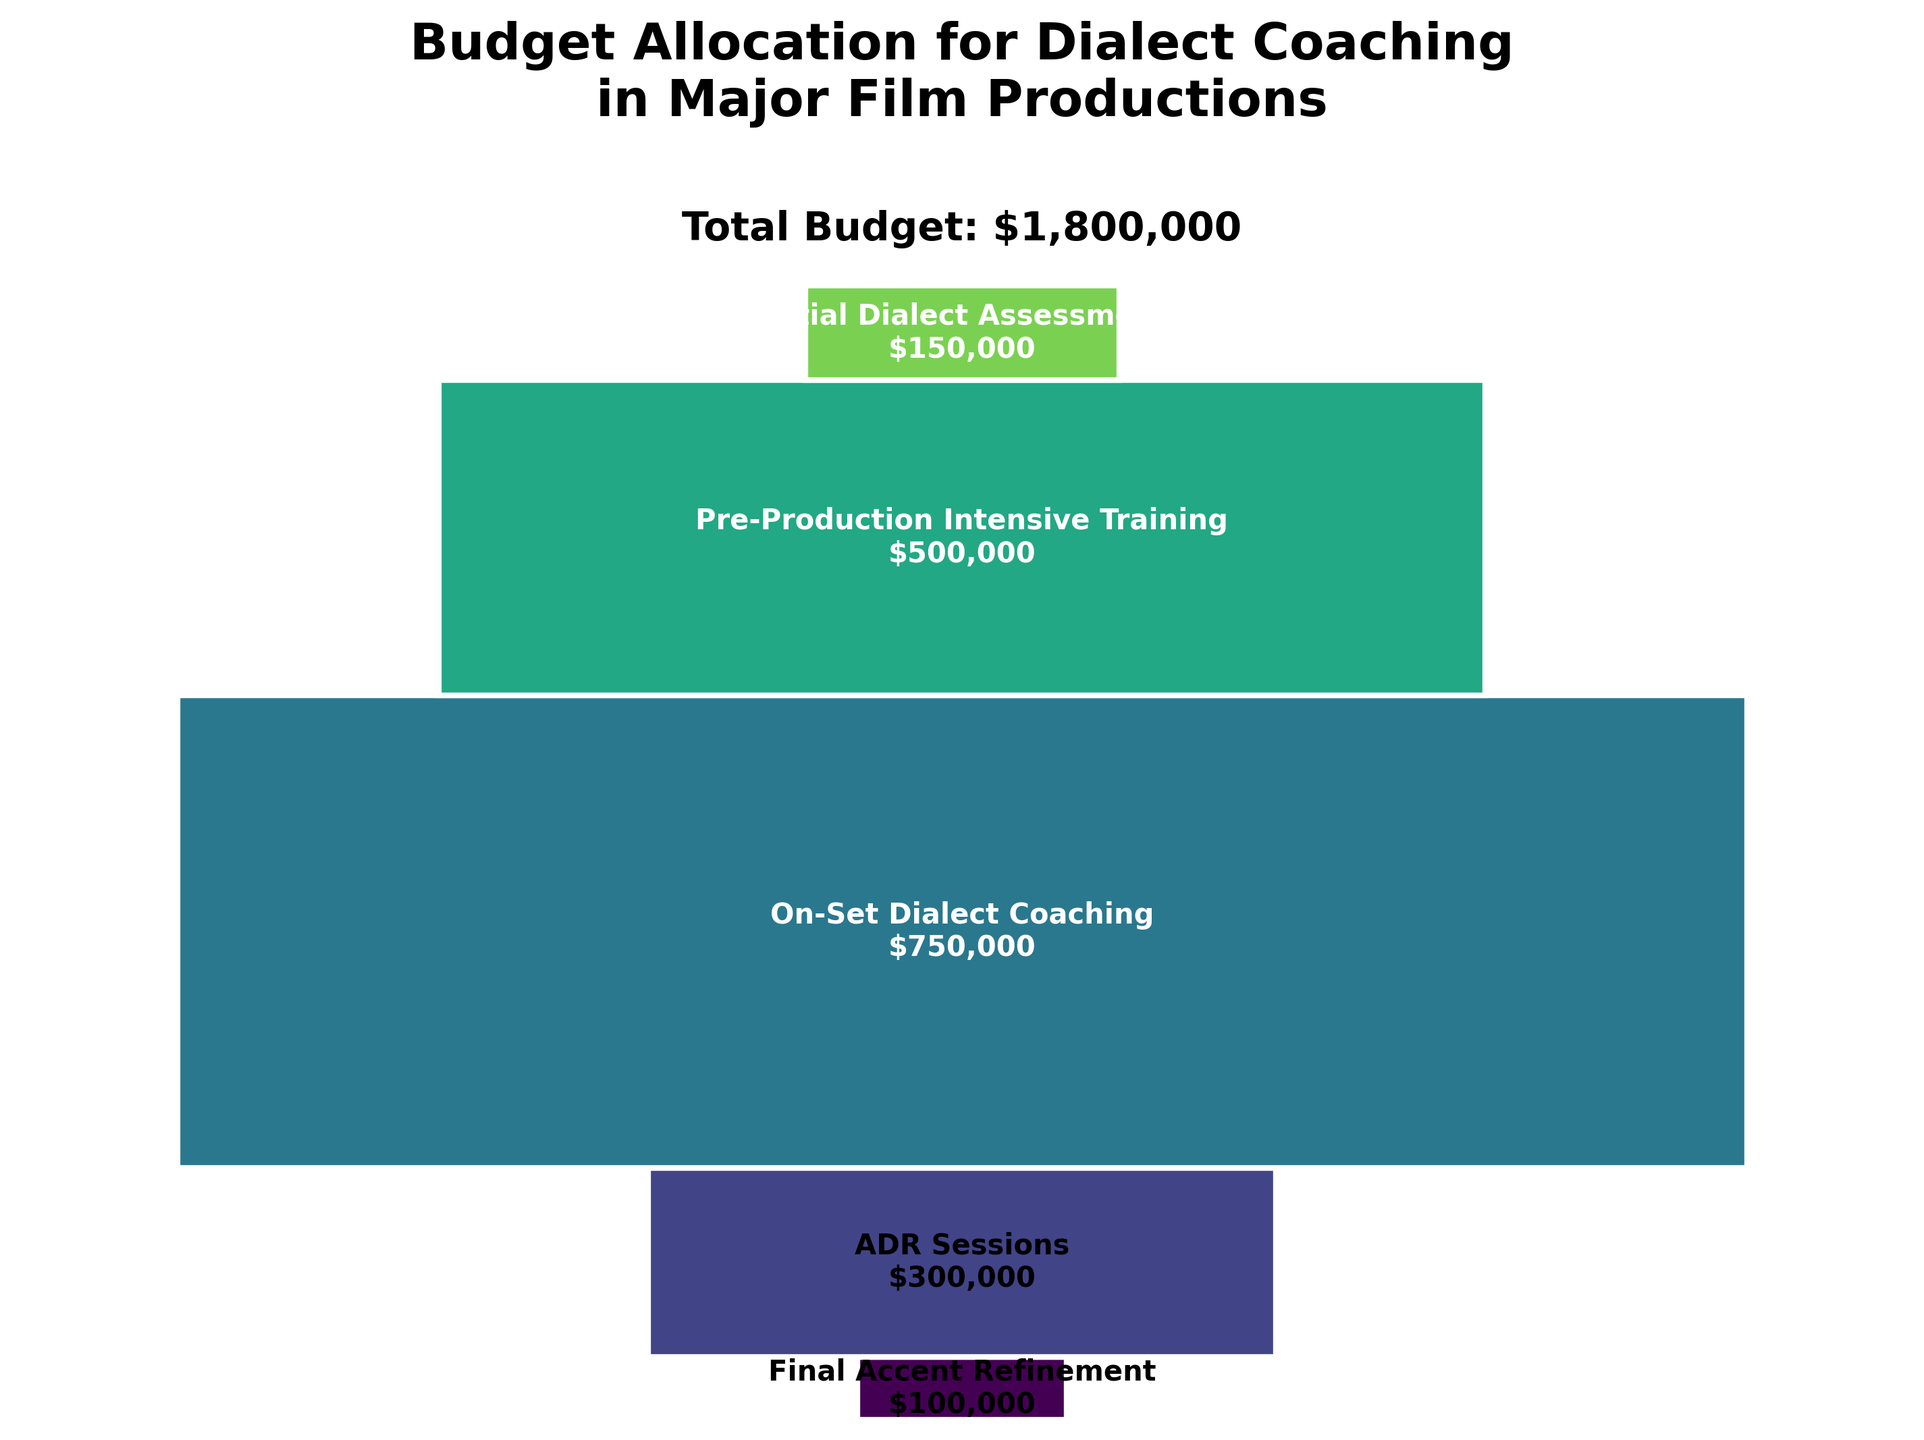What is the title of the plot? The title of the plot is prominently displayed at the top of the figure. It reads "Budget Allocation for Dialect Coaching in Major Film Productions".
Answer: Budget Allocation for Dialect Coaching in Major Film Productions How much budget is allocated for ADR Sessions? The data in the chart shows the budget allocations for different stages. For ADR Sessions, the text displayed within the corresponding bar indicates $300,000.
Answer: $300,000 What stage has the highest budget allocation? By looking at the size of the bars in the funnel chart, the stage with the largest bar represents the highest budget allocation, which is "On-Set Dialect Coaching" with $750,000.
Answer: On-Set Dialect Coaching What is the total budget allocated across all stages? The total budget is shown at the top of the plot, calculated by summing the individual budgets. The total given is $1,800,000.
Answer: $1,800,000 Compare the budget allocation for Pre-Production Intensive Training and Final Accent Refinement. Which one has a higher budget? Pre-Production Intensive Training has a significantly higher budget compared to Final Accent Refinement. The former is $500,000, while the latter is only $100,000, which is shown by the size of the bars in the funnel chart.
Answer: Pre-Production Intensive Training What is the budget difference between Initial Dialect Assessment and Final Accent Refinement? By subtracting the budget for Final Accent Refinement ($100,000) from Initial Dialect Assessment ($150,000), the budget difference is calculated to be $50,000.
Answer: $50,000 How many stages of budget allocation are depicted in the funnel chart? The stages are listed along with their budget allocations in the chart. Counting them gives a total of 5 stages.
Answer: 5 Which stage has the smallest budget allocation, and how does it compare to the most expensive stage? Final Accent Refinement has the smallest budget ($100,000), and On-Set Dialect Coaching has the highest ($750,000). The difference is $750,000 - $100,000, thus Final Accent Refinement's budget is $650,000 less.
Answer: Final Accent Refinement, $650,000 What is the combined budget allocation for On-Set Dialect Coaching and ADR Sessions? Adding the budgets of On-Set Dialect Coaching ($750,000) and ADR Sessions ($300,000) gives a combined total of $1,050,000.
Answer: $1,050,000 How does the budget allocated for Pre-Production Intensive Training compare to that for Initial Dialect Assessment? The budget for Pre-Production Intensive Training is $500,000, which is $350,000 more than Initial Dialect Assessment, which is $150,000.
Answer: $350,000 more 